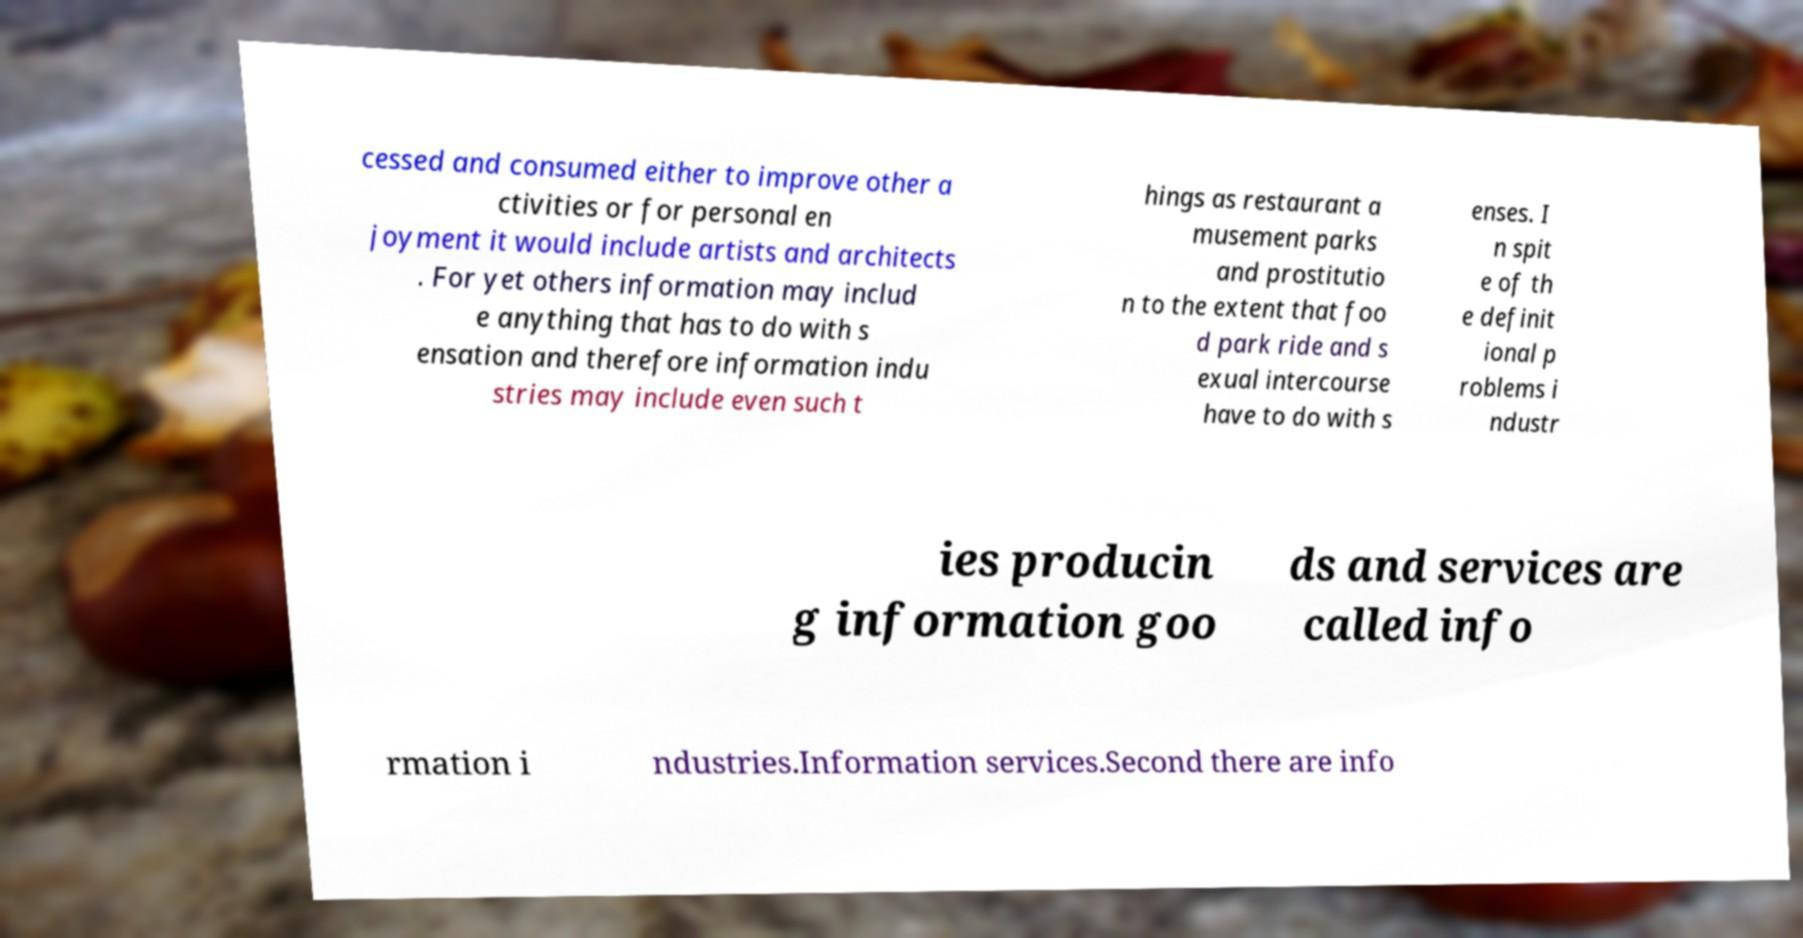What messages or text are displayed in this image? I need them in a readable, typed format. cessed and consumed either to improve other a ctivities or for personal en joyment it would include artists and architects . For yet others information may includ e anything that has to do with s ensation and therefore information indu stries may include even such t hings as restaurant a musement parks and prostitutio n to the extent that foo d park ride and s exual intercourse have to do with s enses. I n spit e of th e definit ional p roblems i ndustr ies producin g information goo ds and services are called info rmation i ndustries.Information services.Second there are info 